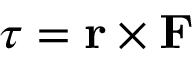Convert formula to latex. <formula><loc_0><loc_0><loc_500><loc_500>{ \tau } = r \times F</formula> 